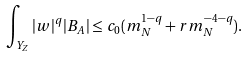Convert formula to latex. <formula><loc_0><loc_0><loc_500><loc_500>\int _ { Y _ { Z } } | w | ^ { q } | B _ { A } | \leq c _ { 0 } ( m _ { N } ^ { 1 - q } + r m _ { N } ^ { - 4 - q } ) .</formula> 